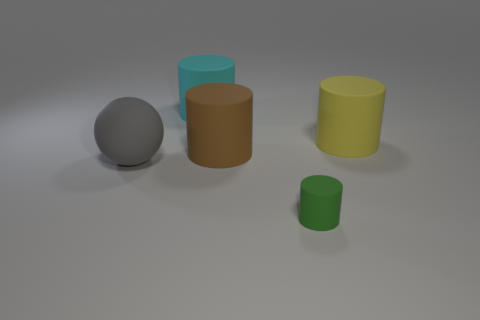What is the color of the big matte thing on the right side of the rubber object in front of the gray thing?
Give a very brief answer. Yellow. Is there another matte object of the same shape as the large brown matte object?
Provide a short and direct response. Yes. There is a rubber object that is on the left side of the cyan matte cylinder; does it have the same size as the cylinder in front of the big gray matte sphere?
Provide a succinct answer. No. What is the size of the yellow thing that is made of the same material as the green thing?
Offer a very short reply. Large. How many rubber cylinders are to the left of the big yellow rubber thing and in front of the cyan rubber thing?
Your answer should be very brief. 2. What number of things are either tiny matte things or rubber cylinders behind the gray matte sphere?
Your answer should be compact. 4. There is a large matte thing that is on the left side of the cyan cylinder; what color is it?
Your answer should be compact. Gray. What number of things are either rubber objects to the left of the big brown object or blocks?
Offer a very short reply. 2. There is a ball that is the same size as the brown cylinder; what is its color?
Your answer should be compact. Gray. Are there more big cylinders that are in front of the yellow matte cylinder than tiny yellow shiny cubes?
Provide a short and direct response. Yes. 